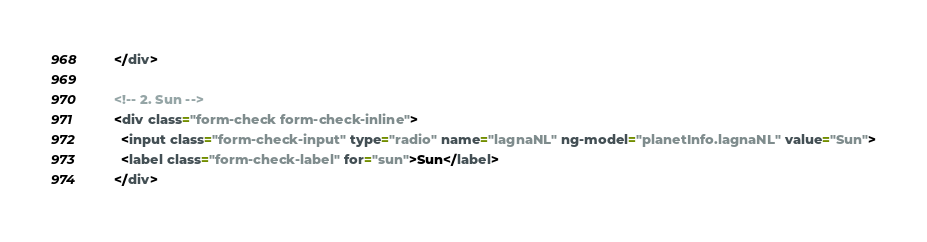Convert code to text. <code><loc_0><loc_0><loc_500><loc_500><_HTML_>      </div>

      <!-- 2. Sun -->
      <div class="form-check form-check-inline">
        <input class="form-check-input" type="radio" name="lagnaNL" ng-model="planetInfo.lagnaNL" value="Sun">
        <label class="form-check-label" for="sun">Sun</label>
      </div>
</code> 